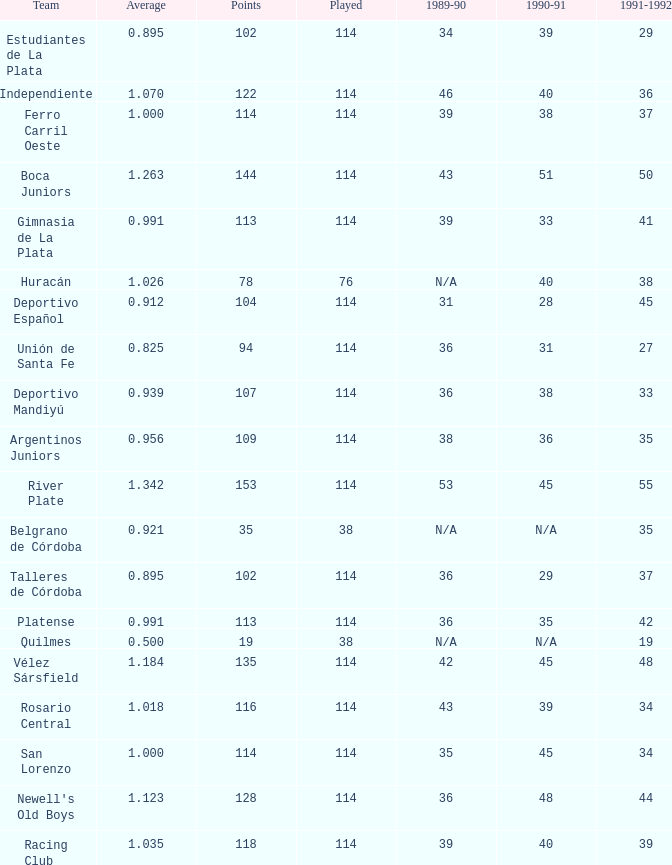How much Average has a 1989-90 of 36, and a Team of talleres de córdoba, and a Played smaller than 114? 0.0. 